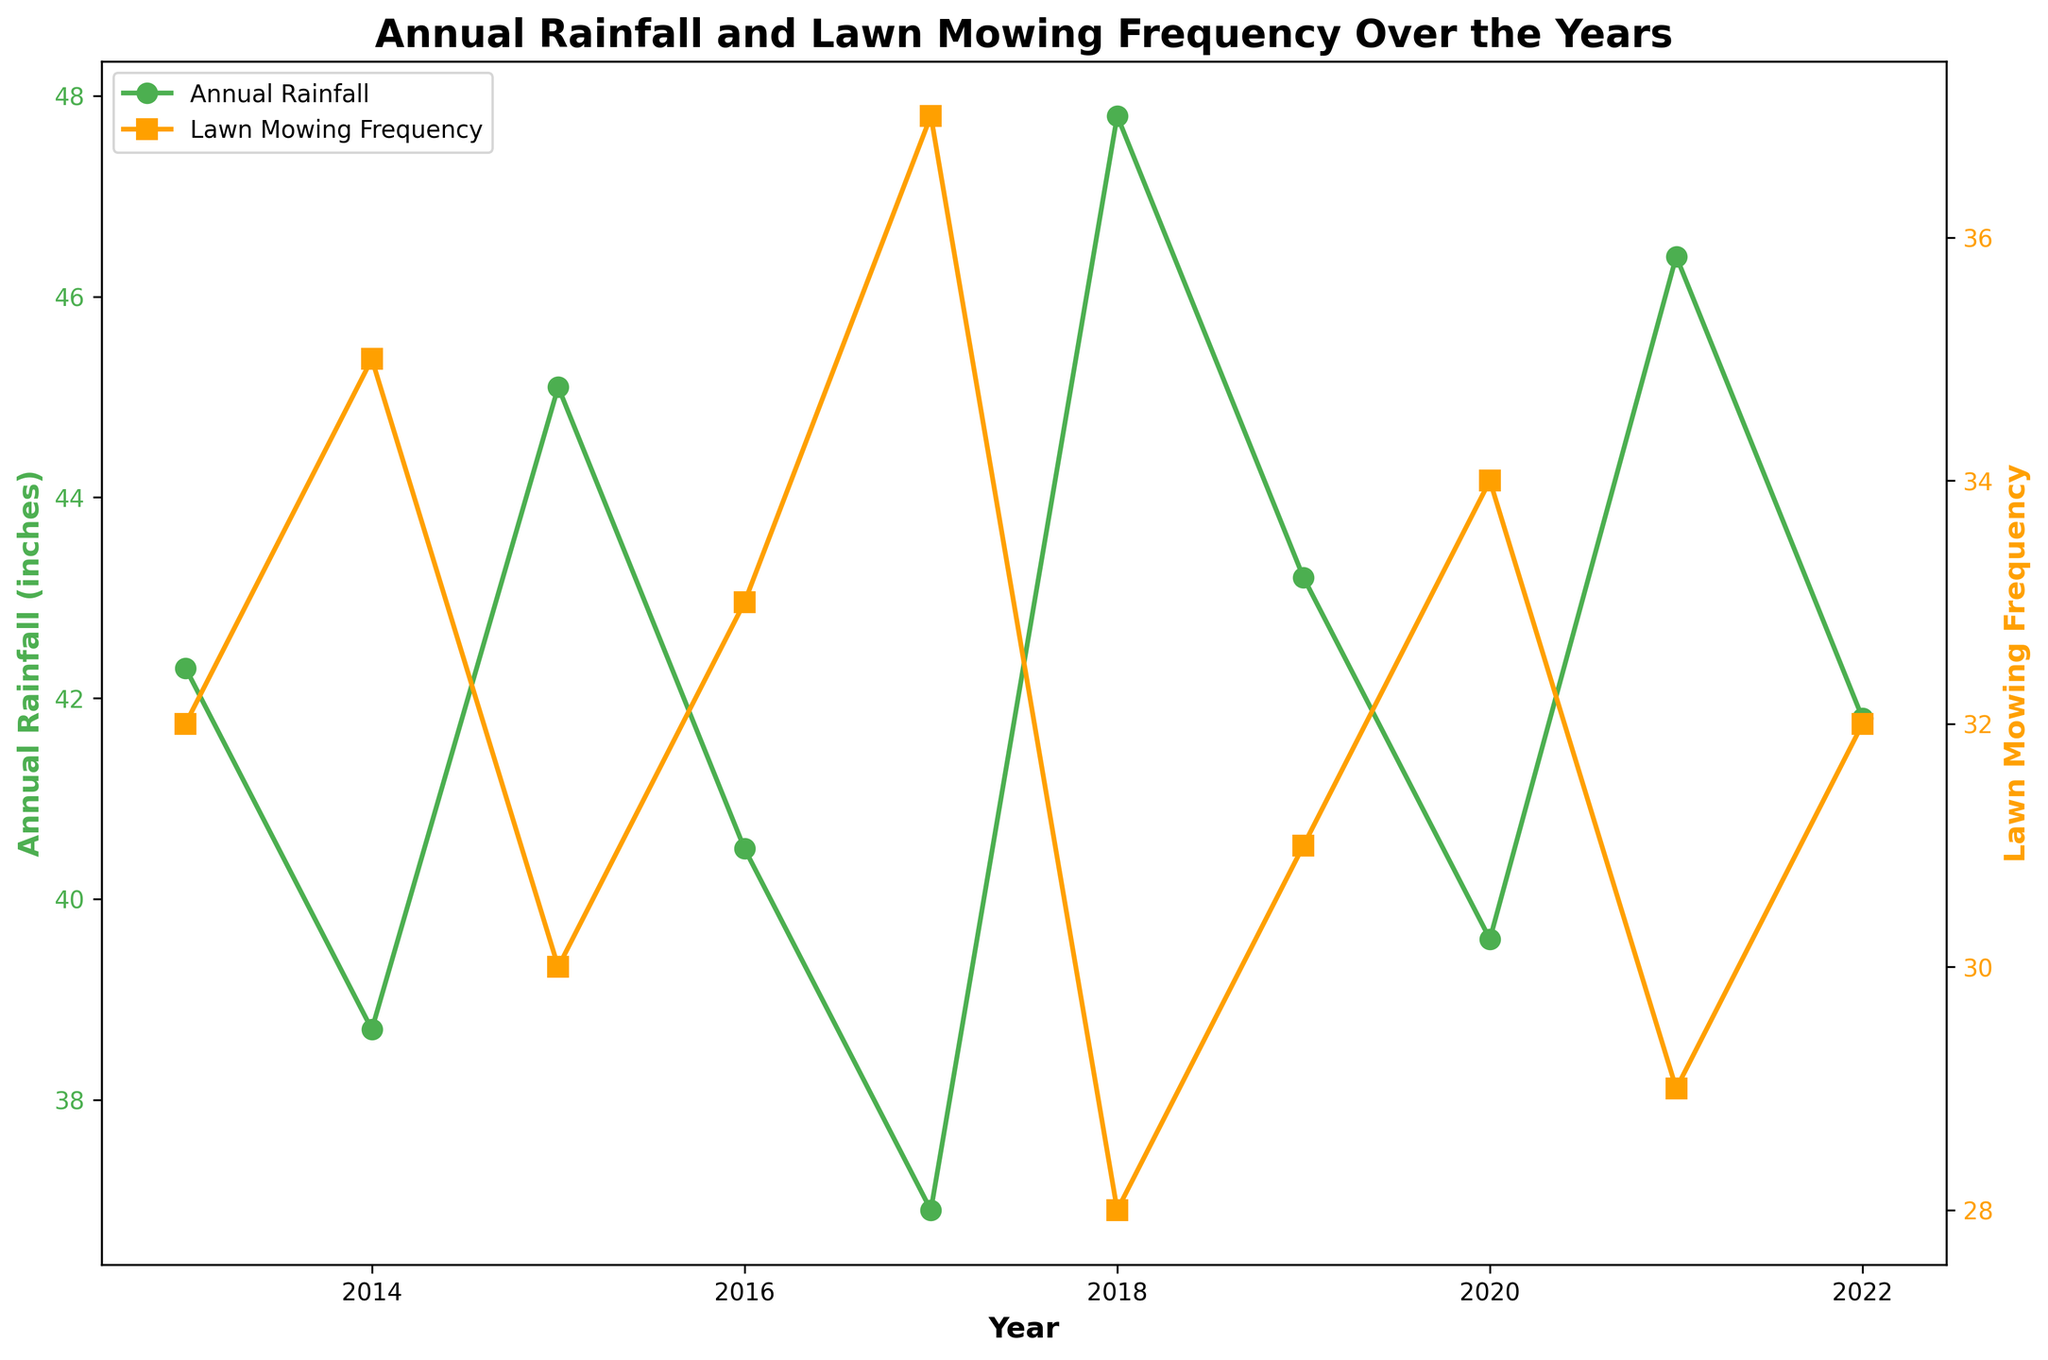What's the general trend of annual rainfall from 2013 to 2022? By looking at the line representing the annual rainfall, we can see the ups and downs over the years. The aim is to identify whether there's an overall increase, decrease, or no significant change over the given period. It appears to fluctuate but does not show a consistent increasing or decreasing trend.
Answer: Fluctuating Which year had the highest lawn mowing frequency, according to the plot? To find this, locate the peak value on the line representing lawn mowing frequency. The year at this peak is the answer.
Answer: 2017 In which year was the difference between annual rainfall and lawn mowing frequency the greatest? To find this, calculate the absolute difference between annual rainfall and lawn mowing frequency for each year, then identify the year with the maximum difference. The largest gap can be visually estimated from the plot itself.
Answer: 2018 How did the annual rainfall change between 2014 and 2015? Look at the values of annual rainfall in 2014 and 2015 and calculate the difference. In the plot, you can directly observe that there's an increase from around 38.7 inches to about 45.1 inches.
Answer: Increased Is there any visible correlation between annual rainfall and lawn mowing frequency over the decade shown? To determine the correlation, visually inspect if there’s a pattern that shows when one variable increases, the other also increases or decreases. Here, increased rainfall often results in reduced mowing frequency.
Answer: Yes, inverse correlation What is the average annual rainfall for the years displayed on the plot? Sum up the annual rainfall values for all years and divide by the number of years (10 in this case): (42.3 + 38.7 + 45.1 + 40.5 + 36.9 + 47.8 + 43.2 + 39.6 + 46.4 + 41.8) / 10
Answer: 42.23 inches Which year had similar values for both annual rainfall and lawn mowing frequency? Compare the values for both metrics across the years to find similar values for a specific year. From the plot, no exact match is perfect, but we look for approximate similarities.
Answer: There is no exact match Did the lawn mowing frequency trend increase or decrease overall from 2013 to 2022? Observing the chart's lawn mowing frequency trend line from the start year to the end year, we can determine the overall direction. Here, some fluctuations exist, but there's a slight decline overall.
Answer: Decreased 